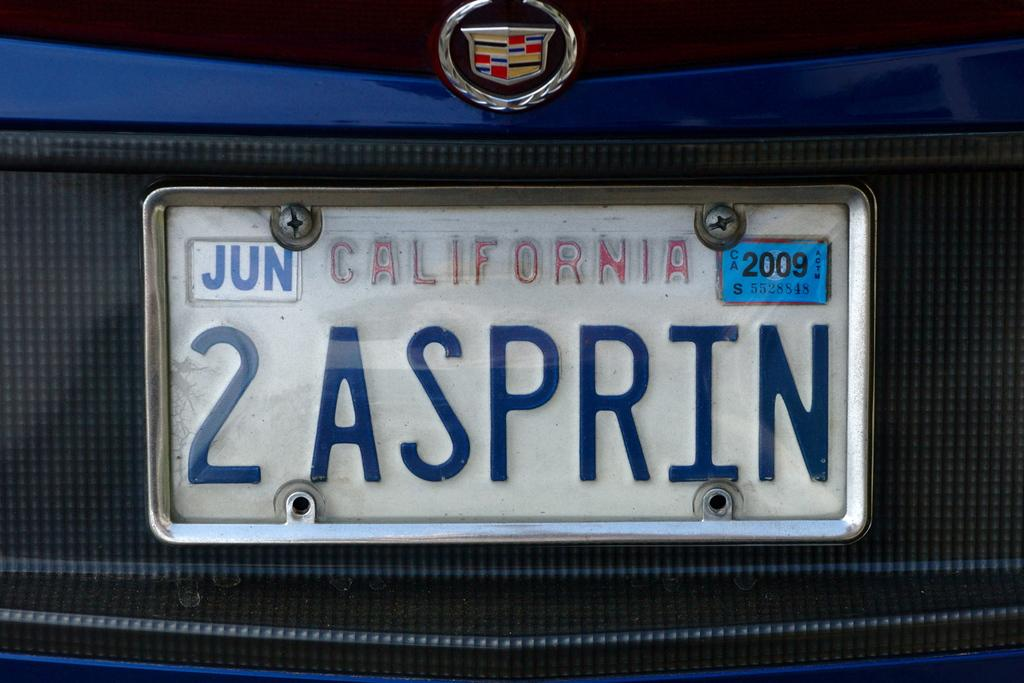<image>
Render a clear and concise summary of the photo. A California license plate, on a Cadillac reads 2 ASPRIN. 